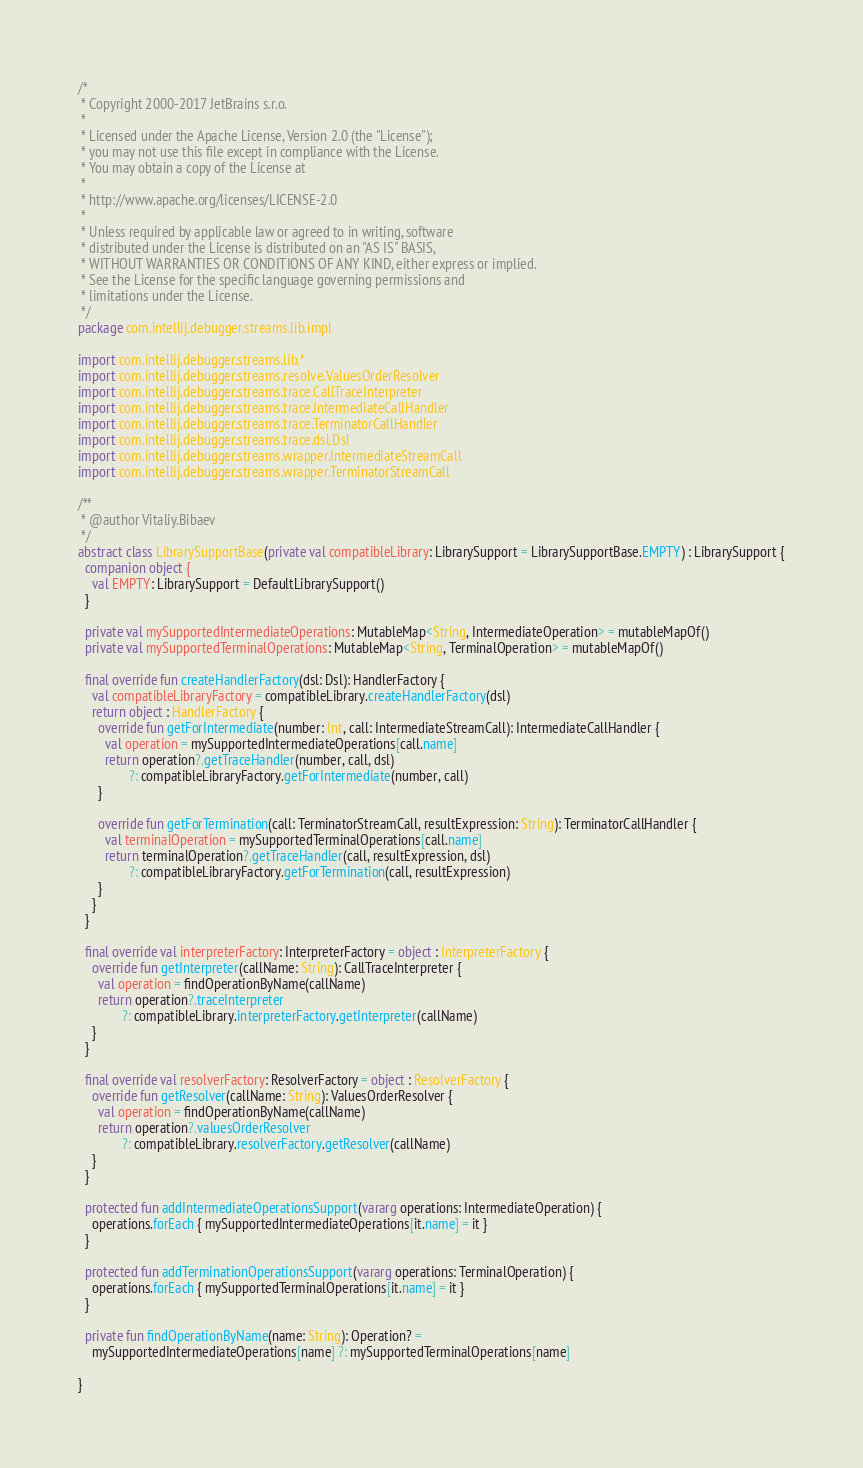Convert code to text. <code><loc_0><loc_0><loc_500><loc_500><_Kotlin_>/*
 * Copyright 2000-2017 JetBrains s.r.o.
 *
 * Licensed under the Apache License, Version 2.0 (the "License");
 * you may not use this file except in compliance with the License.
 * You may obtain a copy of the License at
 *
 * http://www.apache.org/licenses/LICENSE-2.0
 *
 * Unless required by applicable law or agreed to in writing, software
 * distributed under the License is distributed on an "AS IS" BASIS,
 * WITHOUT WARRANTIES OR CONDITIONS OF ANY KIND, either express or implied.
 * See the License for the specific language governing permissions and
 * limitations under the License.
 */
package com.intellij.debugger.streams.lib.impl

import com.intellij.debugger.streams.lib.*
import com.intellij.debugger.streams.resolve.ValuesOrderResolver
import com.intellij.debugger.streams.trace.CallTraceInterpreter
import com.intellij.debugger.streams.trace.IntermediateCallHandler
import com.intellij.debugger.streams.trace.TerminatorCallHandler
import com.intellij.debugger.streams.trace.dsl.Dsl
import com.intellij.debugger.streams.wrapper.IntermediateStreamCall
import com.intellij.debugger.streams.wrapper.TerminatorStreamCall

/**
 * @author Vitaliy.Bibaev
 */
abstract class LibrarySupportBase(private val compatibleLibrary: LibrarySupport = LibrarySupportBase.EMPTY) : LibrarySupport {
  companion object {
    val EMPTY: LibrarySupport = DefaultLibrarySupport()
  }

  private val mySupportedIntermediateOperations: MutableMap<String, IntermediateOperation> = mutableMapOf()
  private val mySupportedTerminalOperations: MutableMap<String, TerminalOperation> = mutableMapOf()

  final override fun createHandlerFactory(dsl: Dsl): HandlerFactory {
    val compatibleLibraryFactory = compatibleLibrary.createHandlerFactory(dsl)
    return object : HandlerFactory {
      override fun getForIntermediate(number: Int, call: IntermediateStreamCall): IntermediateCallHandler {
        val operation = mySupportedIntermediateOperations[call.name]
        return operation?.getTraceHandler(number, call, dsl)
               ?: compatibleLibraryFactory.getForIntermediate(number, call)
      }

      override fun getForTermination(call: TerminatorStreamCall, resultExpression: String): TerminatorCallHandler {
        val terminalOperation = mySupportedTerminalOperations[call.name]
        return terminalOperation?.getTraceHandler(call, resultExpression, dsl)
               ?: compatibleLibraryFactory.getForTermination(call, resultExpression)
      }
    }
  }

  final override val interpreterFactory: InterpreterFactory = object : InterpreterFactory {
    override fun getInterpreter(callName: String): CallTraceInterpreter {
      val operation = findOperationByName(callName)
      return operation?.traceInterpreter
             ?: compatibleLibrary.interpreterFactory.getInterpreter(callName)
    }
  }

  final override val resolverFactory: ResolverFactory = object : ResolverFactory {
    override fun getResolver(callName: String): ValuesOrderResolver {
      val operation = findOperationByName(callName)
      return operation?.valuesOrderResolver
             ?: compatibleLibrary.resolverFactory.getResolver(callName)
    }
  }

  protected fun addIntermediateOperationsSupport(vararg operations: IntermediateOperation) {
    operations.forEach { mySupportedIntermediateOperations[it.name] = it }
  }

  protected fun addTerminationOperationsSupport(vararg operations: TerminalOperation) {
    operations.forEach { mySupportedTerminalOperations[it.name] = it }
  }

  private fun findOperationByName(name: String): Operation? =
    mySupportedIntermediateOperations[name] ?: mySupportedTerminalOperations[name]

}</code> 